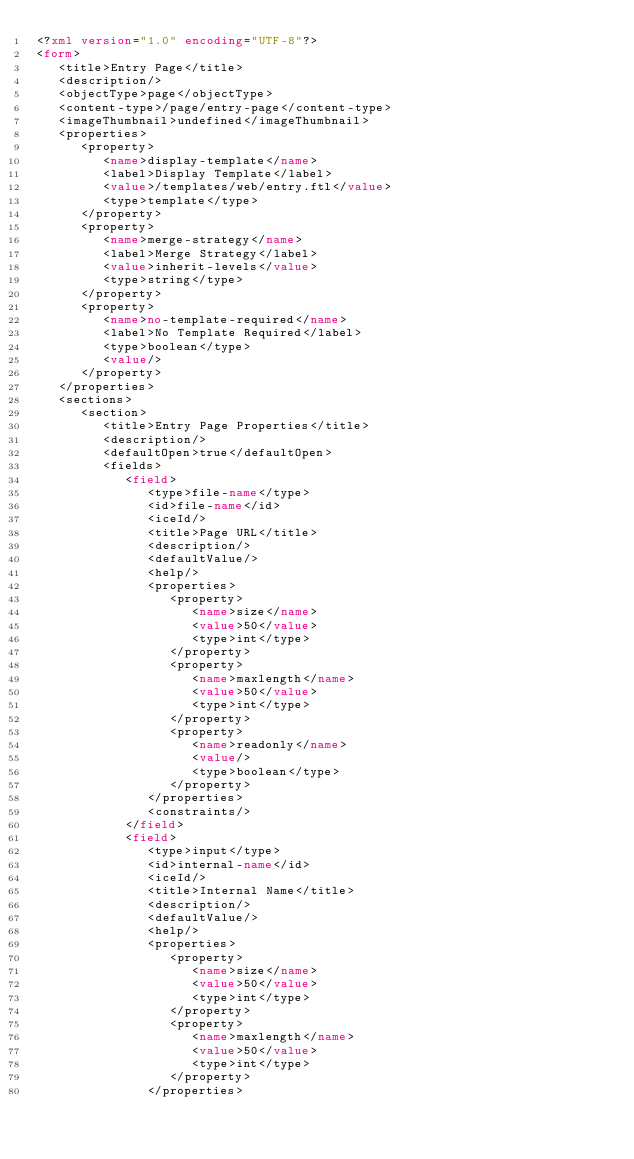Convert code to text. <code><loc_0><loc_0><loc_500><loc_500><_XML_><?xml version="1.0" encoding="UTF-8"?>
<form>
   <title>Entry Page</title>
   <description/>
   <objectType>page</objectType>
   <content-type>/page/entry-page</content-type>
   <imageThumbnail>undefined</imageThumbnail>
   <properties>
      <property>
         <name>display-template</name>
         <label>Display Template</label>
         <value>/templates/web/entry.ftl</value>
         <type>template</type>
      </property>
      <property>
         <name>merge-strategy</name>
         <label>Merge Strategy</label>
         <value>inherit-levels</value>
         <type>string</type>
      </property>
      <property>
         <name>no-template-required</name>
         <label>No Template Required</label>
         <type>boolean</type>
         <value/>
      </property>
   </properties>
   <sections>
      <section>
         <title>Entry Page Properties</title>
         <description/>
         <defaultOpen>true</defaultOpen>
         <fields>
            <field>
               <type>file-name</type>
               <id>file-name</id>
               <iceId/>
               <title>Page URL</title>
               <description/>
               <defaultValue/>
               <help/>
               <properties>
                  <property>
                     <name>size</name>
                     <value>50</value>
                     <type>int</type>
                  </property>
                  <property>
                     <name>maxlength</name>
                     <value>50</value>
                     <type>int</type>
                  </property>
                  <property>
                     <name>readonly</name>
                     <value/>
                     <type>boolean</type>
                  </property>
               </properties>
               <constraints/>
            </field>
            <field>
               <type>input</type>
               <id>internal-name</id>
               <iceId/>
               <title>Internal Name</title>
               <description/>
               <defaultValue/>
               <help/>
               <properties>
                  <property>
                     <name>size</name>
                     <value>50</value>
                     <type>int</type>
                  </property>
                  <property>
                     <name>maxlength</name>
                     <value>50</value>
                     <type>int</type>
                  </property>
               </properties></code> 